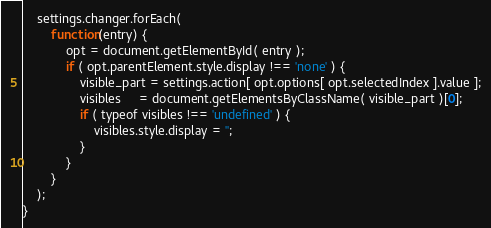Convert code to text. <code><loc_0><loc_0><loc_500><loc_500><_JavaScript_>	settings.changer.forEach(
		function(entry) {
			opt = document.getElementById( entry );
			if ( opt.parentElement.style.display !== 'none' ) {
				visible_part = settings.action[ opt.options[ opt.selectedIndex ].value ];
				visibles     = document.getElementsByClassName( visible_part )[0];
				if ( typeof visibles !== 'undefined' ) {
					visibles.style.display = '';
				}
			}
		}
	);
}
</code> 